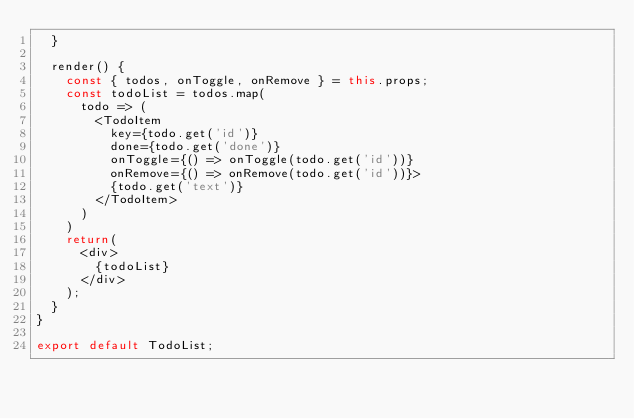<code> <loc_0><loc_0><loc_500><loc_500><_JavaScript_>  }

  render() {
    const { todos, onToggle, onRemove } = this.props;
    const todoList = todos.map(
      todo => (
        <TodoItem
          key={todo.get('id')}
          done={todo.get('done')}
          onToggle={() => onToggle(todo.get('id'))}
          onRemove={() => onRemove(todo.get('id'))}>
          {todo.get('text')}
        </TodoItem>
      )
    )
    return(
      <div>
        {todoList}
      </div>
    );
  }
}

export default TodoList;</code> 